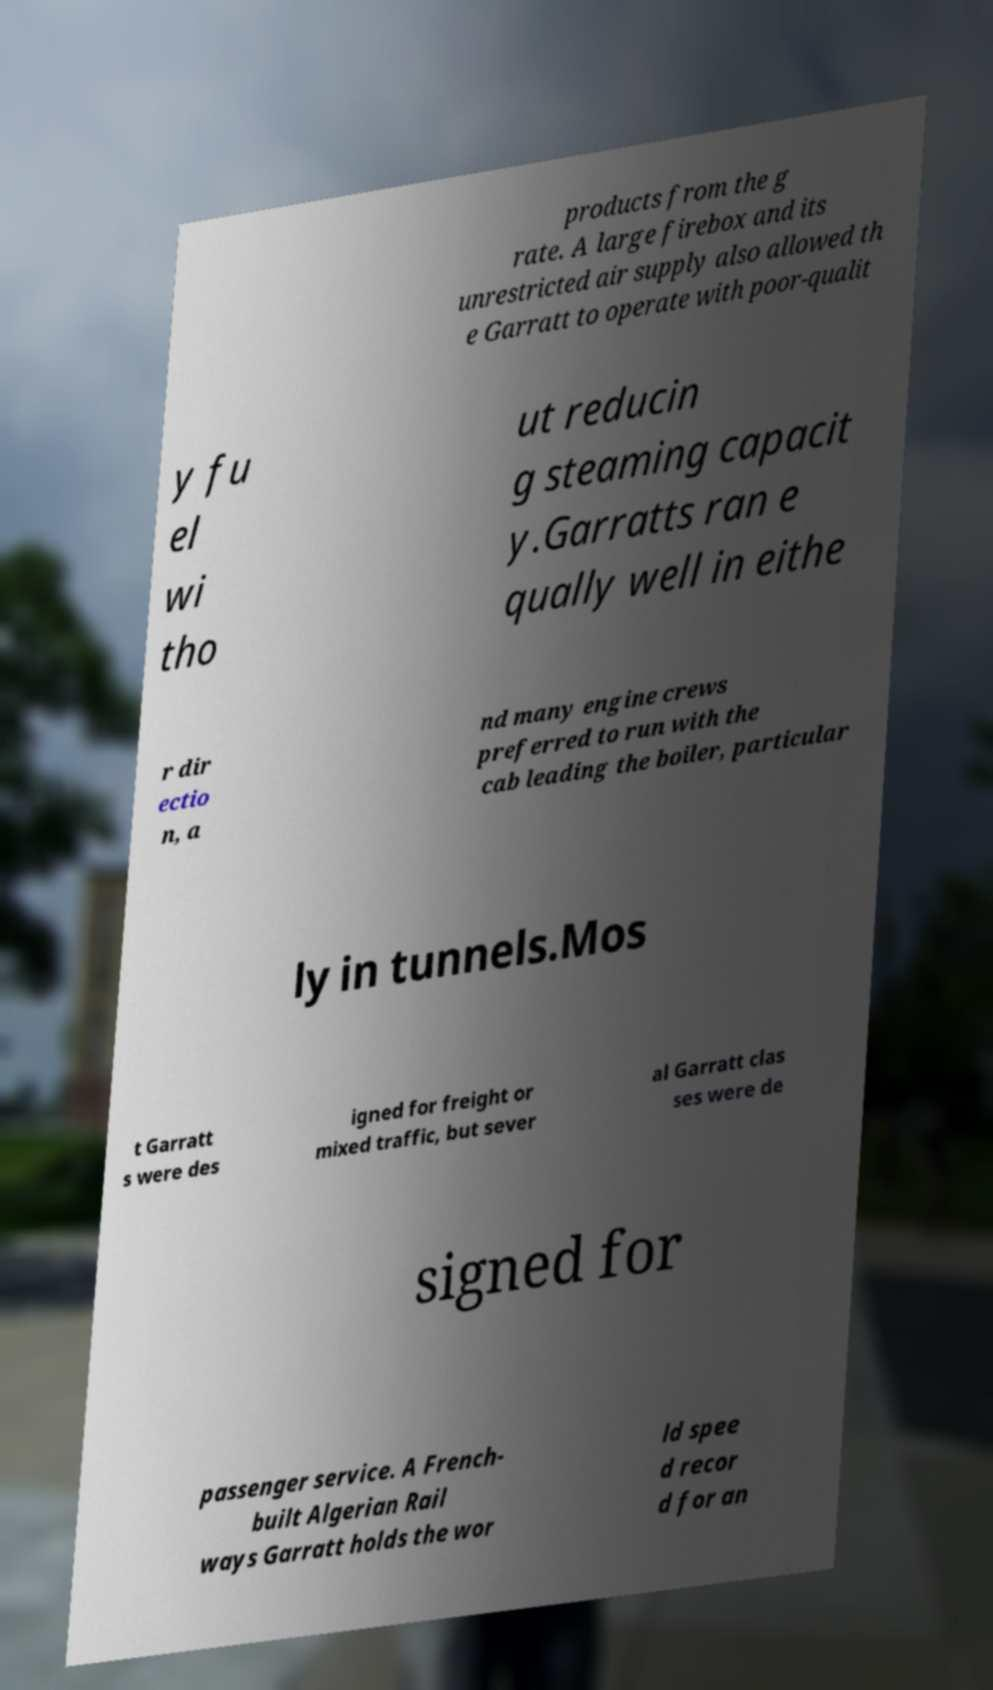What messages or text are displayed in this image? I need them in a readable, typed format. products from the g rate. A large firebox and its unrestricted air supply also allowed th e Garratt to operate with poor-qualit y fu el wi tho ut reducin g steaming capacit y.Garratts ran e qually well in eithe r dir ectio n, a nd many engine crews preferred to run with the cab leading the boiler, particular ly in tunnels.Mos t Garratt s were des igned for freight or mixed traffic, but sever al Garratt clas ses were de signed for passenger service. A French- built Algerian Rail ways Garratt holds the wor ld spee d recor d for an 